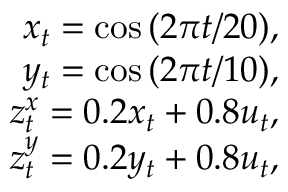<formula> <loc_0><loc_0><loc_500><loc_500>\begin{array} { r } { x _ { t } = \cos { ( 2 \pi t / 2 0 ) } , } \\ { y _ { t } = \cos { ( 2 \pi t / 1 0 ) } , } \\ { z _ { t } ^ { x } = 0 . 2 x _ { t } + 0 . 8 u _ { t } , } \\ { z _ { t } ^ { y } = 0 . 2 y _ { t } + 0 . 8 u _ { t } , } \end{array}</formula> 